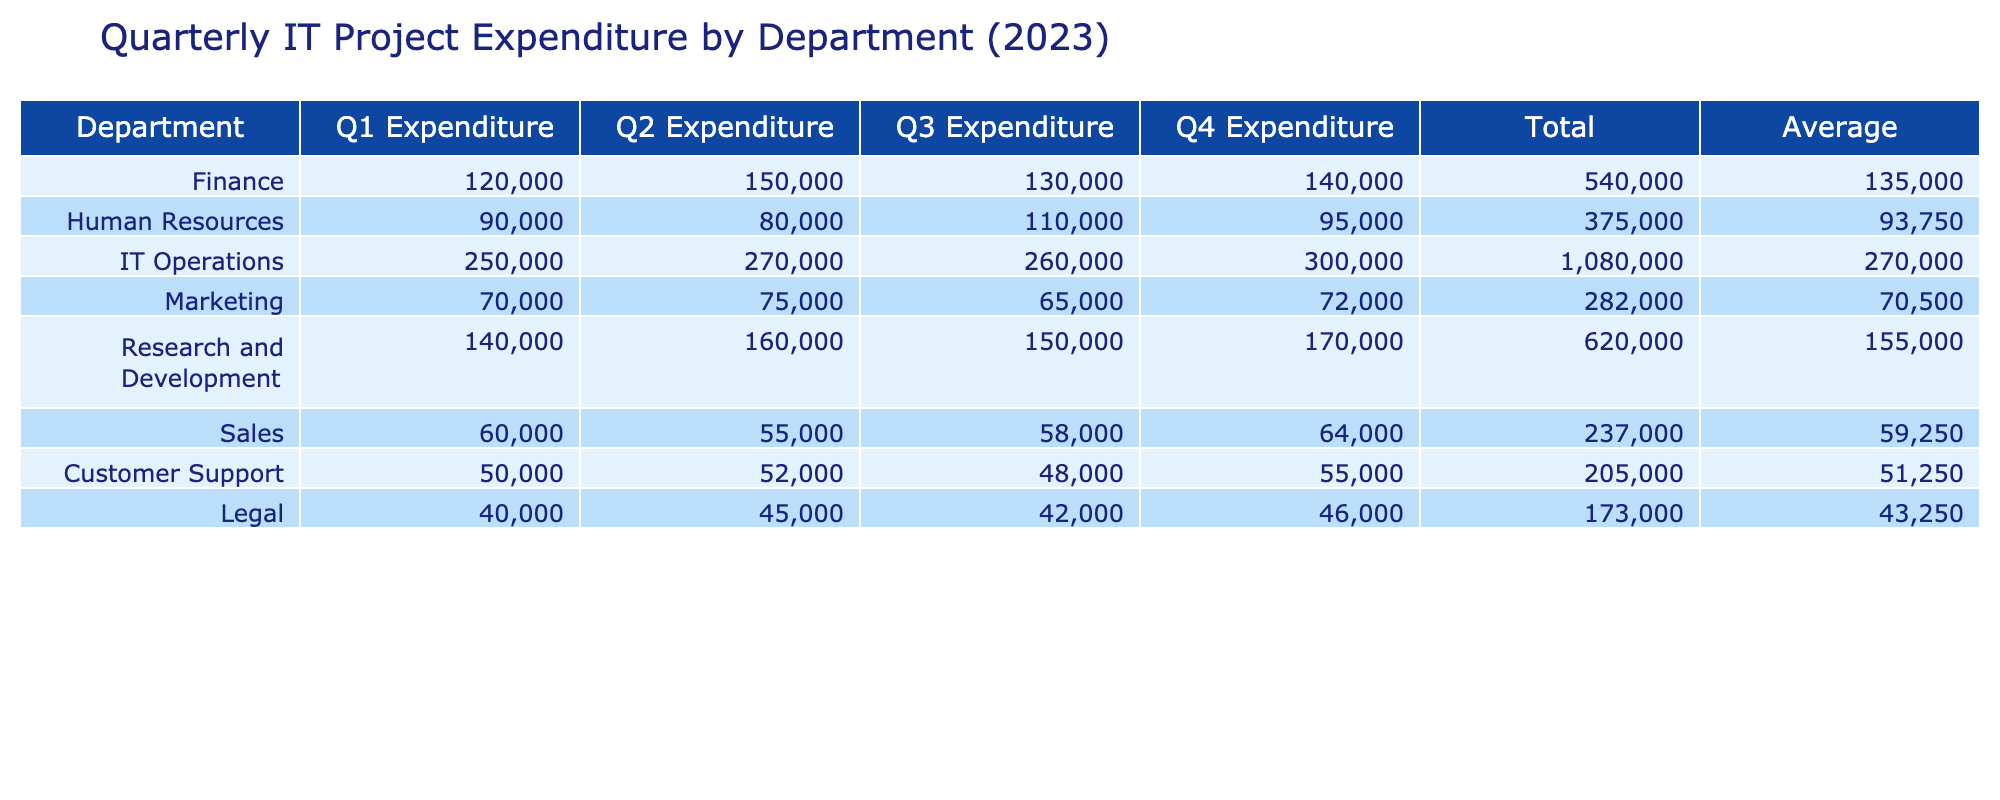What is the total expenditure for the IT Operations department in Q2? The Q2 expenditure for IT Operations is directly listed in the table as 270000.
Answer: 270000 Which department had the highest total expenditure for the year? To find the total expenditure for each department, I need to add their quarterly expenditures: IT Operations (250000 + 270000 + 260000 + 300000 = 1080000) has the highest total compared to others.
Answer: IT Operations What is the average expenditure of the Human Resources department across all quarters? To find the average, I sum the quarterly expenditures (90000 + 80000 + 110000 + 95000) = 385000, then divide by the number of quarters (4): 385000 / 4 = 96250.
Answer: 96250 Did the Customer Support department spend more in Q4 than in Q3? The Q4 expenditure for Customer Support is 55000, and for Q3, it is 48000. Since 55000 is greater than 48000, the statement is true.
Answer: Yes What is the difference in total expenditure between the Finance and Research and Development departments? First, I calculate the total for each: Finance (120000 + 150000 + 130000 + 140000 = 540000), Research and Development (140000 + 160000 + 150000 + 170000 = 620000). The difference is 620000 - 540000 = 80000.
Answer: 80000 What was the Q1 expenditure for the Marketing department compared to the Customer Support department? The Q1 expenditure for Marketing is 70000, and for Customer Support, it is 50000. Since 70000 is greater than 50000, the Q1 expenditure for Marketing was higher.
Answer: Yes What was the total expenditure for the Sales department in 2023? The total for the Sales department is the sum of all quarters: 60000 + 55000 + 58000 + 64000 = 237000.
Answer: 237000 Which department spent the least in Q2? The expenditure for each department in Q2 is Human Resources (80000), Marketing (75000), Sales (55000), Customer Support (52000), and Legal (45000). The lowest expenditure is from Legal, which spent 45000.
Answer: Legal Was the average expenditure across all departments higher in Q3 than in Q1? The total expenditure in Q1 is 120000 (Finance) + 90000 (HR) + 250000 (IT) + 70000 (Marketing) + 140000 (R&D) + 60000 (Sales) + 50000 (CS) + 40000 (Legal) = 1310000 and in Q3 is 130000 + 110000 + 260000 + 65000 + 150000 + 58000 + 48000 + 42000 = 1310000. Both averages in Q1 and Q3 amount to the same, so the answer is no.
Answer: No 